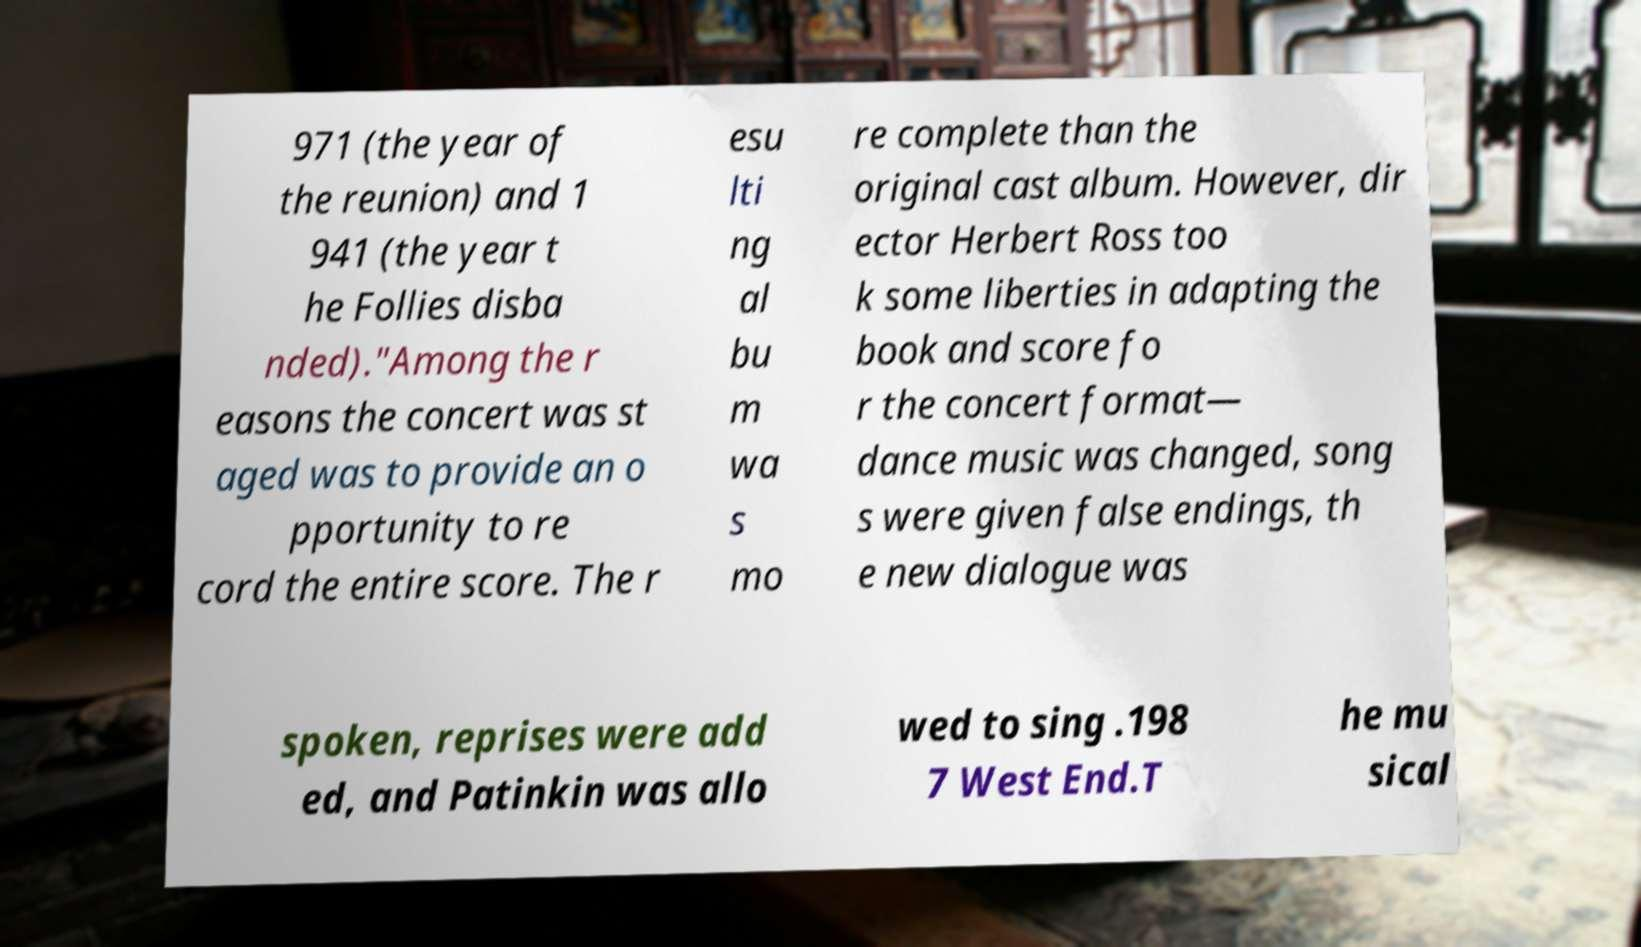There's text embedded in this image that I need extracted. Can you transcribe it verbatim? 971 (the year of the reunion) and 1 941 (the year t he Follies disba nded)."Among the r easons the concert was st aged was to provide an o pportunity to re cord the entire score. The r esu lti ng al bu m wa s mo re complete than the original cast album. However, dir ector Herbert Ross too k some liberties in adapting the book and score fo r the concert format— dance music was changed, song s were given false endings, th e new dialogue was spoken, reprises were add ed, and Patinkin was allo wed to sing .198 7 West End.T he mu sical 